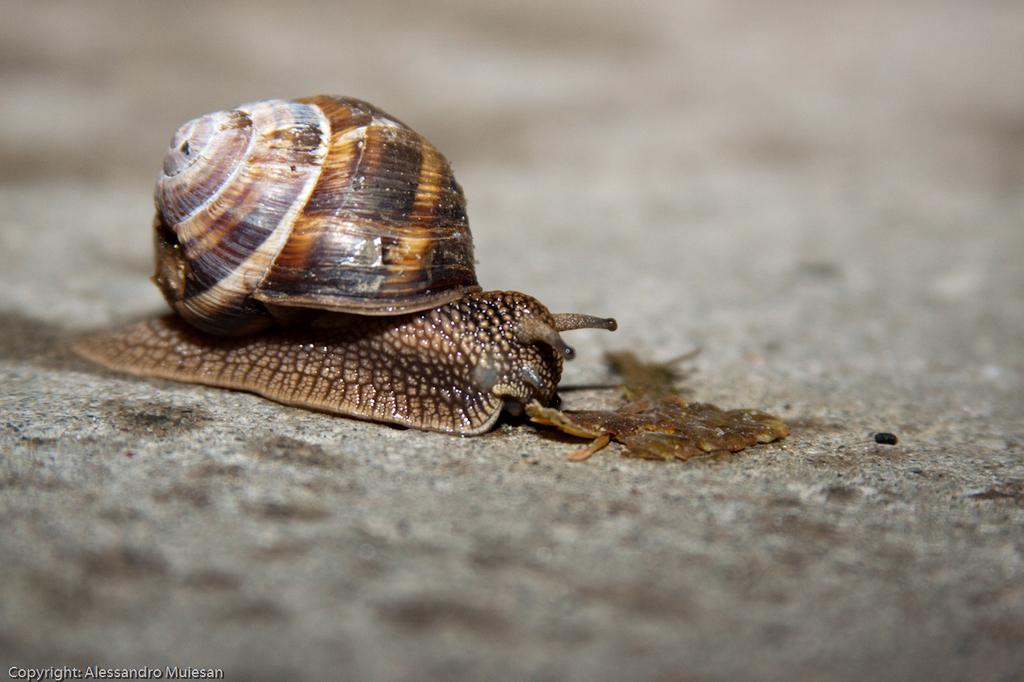What type of animal is present in the image? There is a snail in the image. Can you describe the snail's location in the image? The snail is on the surface. What type of scent does the snail emit in the image? Snails do not emit scents, so there is no scent associated with the snail in the image. How high does the snail jump in the image? Snails do not jump, so there is no jumping action associated with the snail in the image. 